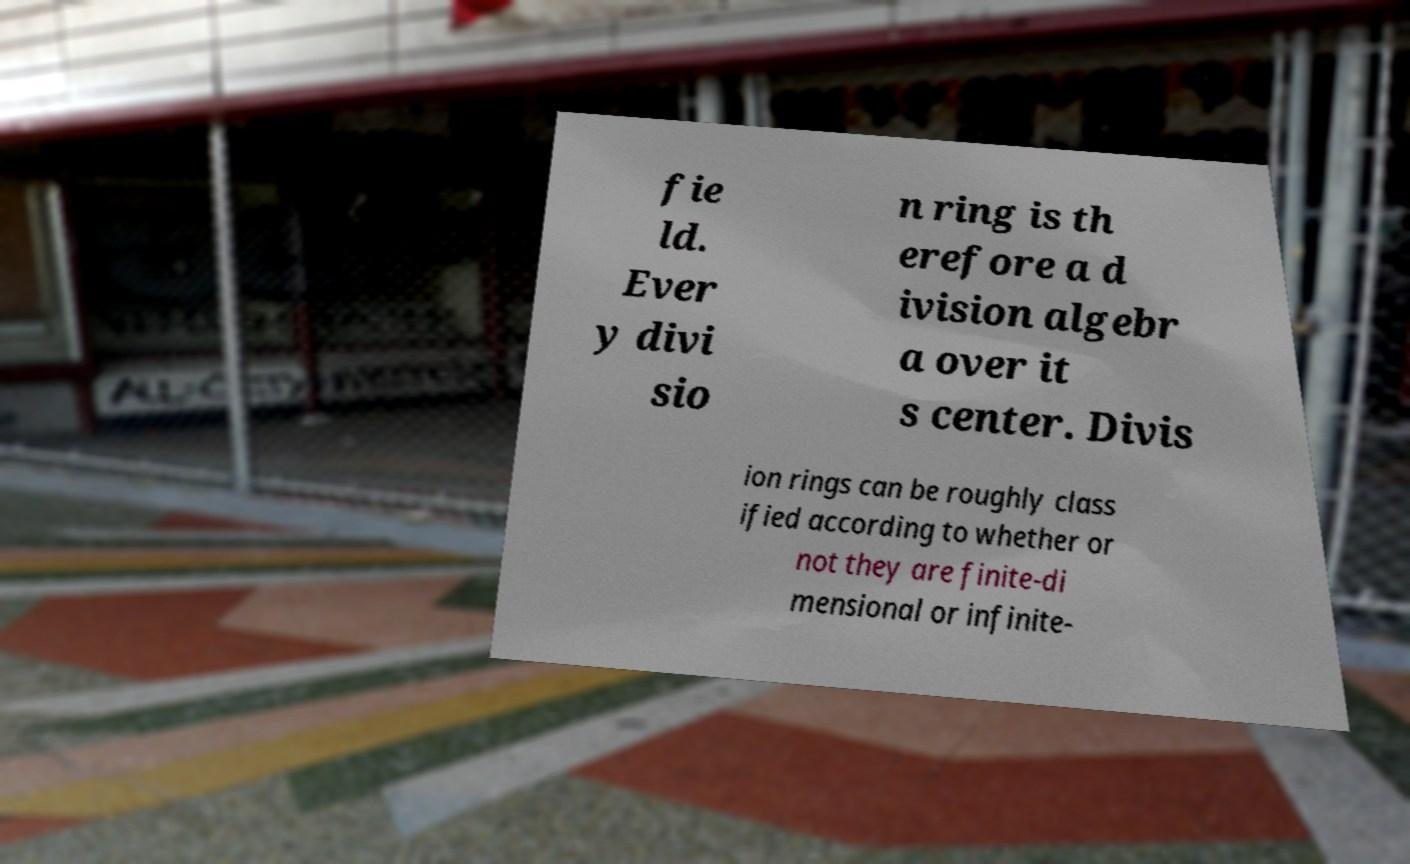Please read and relay the text visible in this image. What does it say? fie ld. Ever y divi sio n ring is th erefore a d ivision algebr a over it s center. Divis ion rings can be roughly class ified according to whether or not they are finite-di mensional or infinite- 